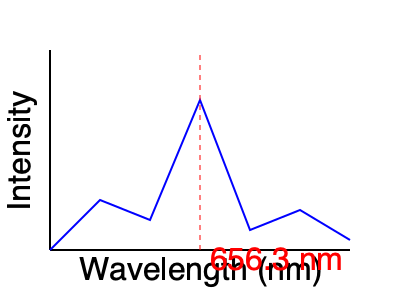In the spectral analysis of a distant star, a prominent absorption line is observed at 656.3 nm, as shown in the graph. What element does this spectral line likely indicate, and how might this information be relevant to the search for potential biosignatures? To answer this question, let's break it down into steps:

1. Identifying the spectral line:
   The absorption line at 656.3 nm is a well-known spectral feature called the Hydrogen-alpha (H$\alpha$) line.

2. Understanding the significance of H$\alpha$:
   - H$\alpha$ is part of the Balmer series for hydrogen.
   - It represents the transition of an electron in a hydrogen atom from the n=3 to n=2 energy level.
   - The energy of this transition is given by the equation:
     $$E = hc / \lambda$$
     where h is Planck's constant, c is the speed of light, and $\lambda$ is the wavelength (656.3 nm).

3. Relevance to biosignatures:
   - Hydrogen is the most abundant element in the universe and a key component of water (H$_2$O).
   - The presence of hydrogen, particularly in the form of water, is crucial for life as we know it.
   - While the H$\alpha$ line alone is not a biosignature, it can indicate the presence of hydrogen in a star's atmosphere or surrounding gas clouds.

4. Implications for exoplanet research:
   - Stars with strong hydrogen signatures may have planetary systems with hydrogen-rich atmospheres.
   - Such atmospheres could potentially support the formation of water and other molecules necessary for life.

5. Context in astrobiology:
   - The detection of hydrogen, along with other elements like oxygen, carbon, and nitrogen, can help identify potential habitable environments.
   - Spectral analysis of exoplanet atmospheres, using similar techniques, can reveal the presence of these elements and potential biosignature gases like methane or oxygen.

In conclusion, while the H$\alpha$ line itself is not a direct biosignature, its presence provides valuable information about the composition of stellar systems and can guide further investigations into potential habitable environments around distant stars.
Answer: Hydrogen; indicates presence of a key element for life, guiding further biosignature investigations. 